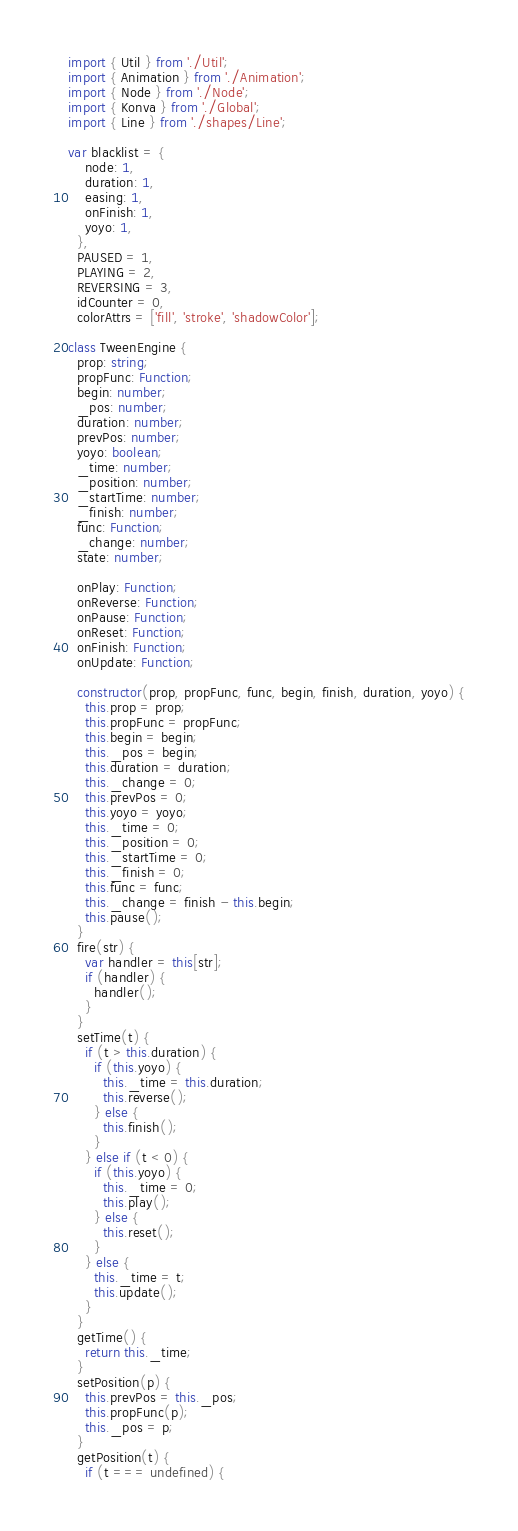<code> <loc_0><loc_0><loc_500><loc_500><_TypeScript_>import { Util } from './Util';
import { Animation } from './Animation';
import { Node } from './Node';
import { Konva } from './Global';
import { Line } from './shapes/Line';

var blacklist = {
    node: 1,
    duration: 1,
    easing: 1,
    onFinish: 1,
    yoyo: 1,
  },
  PAUSED = 1,
  PLAYING = 2,
  REVERSING = 3,
  idCounter = 0,
  colorAttrs = ['fill', 'stroke', 'shadowColor'];

class TweenEngine {
  prop: string;
  propFunc: Function;
  begin: number;
  _pos: number;
  duration: number;
  prevPos: number;
  yoyo: boolean;
  _time: number;
  _position: number;
  _startTime: number;
  _finish: number;
  func: Function;
  _change: number;
  state: number;

  onPlay: Function;
  onReverse: Function;
  onPause: Function;
  onReset: Function;
  onFinish: Function;
  onUpdate: Function;

  constructor(prop, propFunc, func, begin, finish, duration, yoyo) {
    this.prop = prop;
    this.propFunc = propFunc;
    this.begin = begin;
    this._pos = begin;
    this.duration = duration;
    this._change = 0;
    this.prevPos = 0;
    this.yoyo = yoyo;
    this._time = 0;
    this._position = 0;
    this._startTime = 0;
    this._finish = 0;
    this.func = func;
    this._change = finish - this.begin;
    this.pause();
  }
  fire(str) {
    var handler = this[str];
    if (handler) {
      handler();
    }
  }
  setTime(t) {
    if (t > this.duration) {
      if (this.yoyo) {
        this._time = this.duration;
        this.reverse();
      } else {
        this.finish();
      }
    } else if (t < 0) {
      if (this.yoyo) {
        this._time = 0;
        this.play();
      } else {
        this.reset();
      }
    } else {
      this._time = t;
      this.update();
    }
  }
  getTime() {
    return this._time;
  }
  setPosition(p) {
    this.prevPos = this._pos;
    this.propFunc(p);
    this._pos = p;
  }
  getPosition(t) {
    if (t === undefined) {</code> 